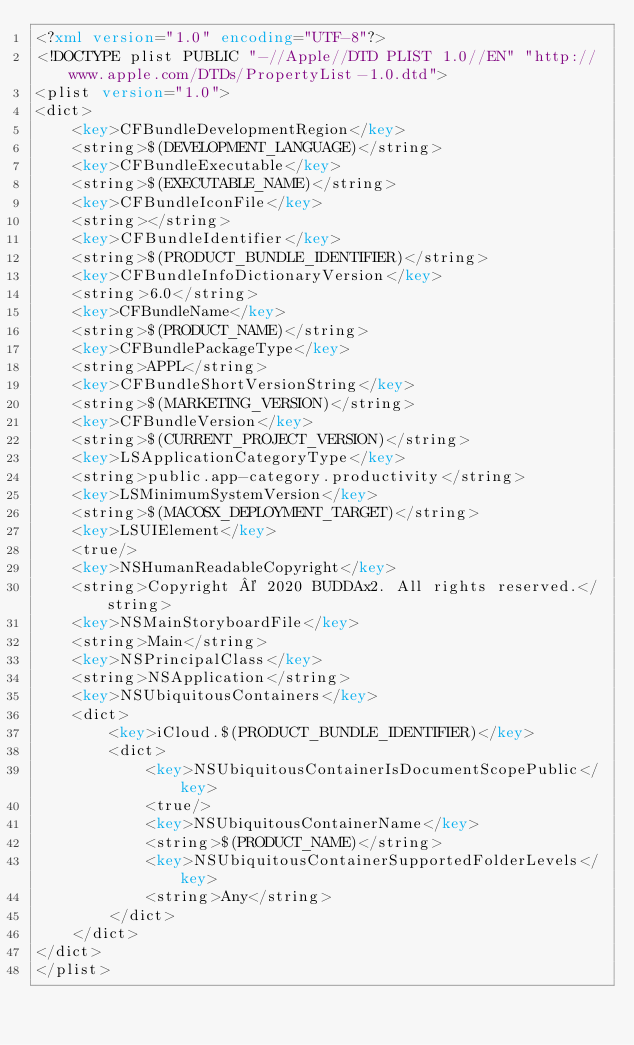Convert code to text. <code><loc_0><loc_0><loc_500><loc_500><_XML_><?xml version="1.0" encoding="UTF-8"?>
<!DOCTYPE plist PUBLIC "-//Apple//DTD PLIST 1.0//EN" "http://www.apple.com/DTDs/PropertyList-1.0.dtd">
<plist version="1.0">
<dict>
	<key>CFBundleDevelopmentRegion</key>
	<string>$(DEVELOPMENT_LANGUAGE)</string>
	<key>CFBundleExecutable</key>
	<string>$(EXECUTABLE_NAME)</string>
	<key>CFBundleIconFile</key>
	<string></string>
	<key>CFBundleIdentifier</key>
	<string>$(PRODUCT_BUNDLE_IDENTIFIER)</string>
	<key>CFBundleInfoDictionaryVersion</key>
	<string>6.0</string>
	<key>CFBundleName</key>
	<string>$(PRODUCT_NAME)</string>
	<key>CFBundlePackageType</key>
	<string>APPL</string>
	<key>CFBundleShortVersionString</key>
	<string>$(MARKETING_VERSION)</string>
	<key>CFBundleVersion</key>
	<string>$(CURRENT_PROJECT_VERSION)</string>
	<key>LSApplicationCategoryType</key>
	<string>public.app-category.productivity</string>
	<key>LSMinimumSystemVersion</key>
	<string>$(MACOSX_DEPLOYMENT_TARGET)</string>
	<key>LSUIElement</key>
	<true/>
	<key>NSHumanReadableCopyright</key>
	<string>Copyright © 2020 BUDDAx2. All rights reserved.</string>
	<key>NSMainStoryboardFile</key>
	<string>Main</string>
	<key>NSPrincipalClass</key>
	<string>NSApplication</string>
	<key>NSUbiquitousContainers</key>
	<dict>
		<key>iCloud.$(PRODUCT_BUNDLE_IDENTIFIER)</key>
		<dict>
			<key>NSUbiquitousContainerIsDocumentScopePublic</key>
			<true/>
			<key>NSUbiquitousContainerName</key>
			<string>$(PRODUCT_NAME)</string>
			<key>NSUbiquitousContainerSupportedFolderLevels</key>
			<string>Any</string>
		</dict>
	</dict>
</dict>
</plist>
</code> 